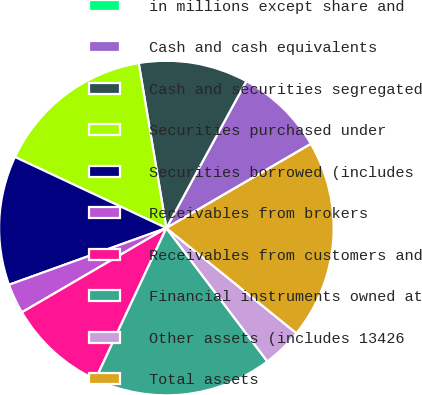<chart> <loc_0><loc_0><loc_500><loc_500><pie_chart><fcel>in millions except share and<fcel>Cash and cash equivalents<fcel>Cash and securities segregated<fcel>Securities purchased under<fcel>Securities borrowed (includes<fcel>Receivables from brokers<fcel>Receivables from customers and<fcel>Financial instruments owned at<fcel>Other assets (includes 13426<fcel>Total assets<nl><fcel>0.02%<fcel>8.66%<fcel>10.58%<fcel>15.37%<fcel>12.49%<fcel>2.9%<fcel>9.62%<fcel>17.29%<fcel>3.86%<fcel>19.21%<nl></chart> 